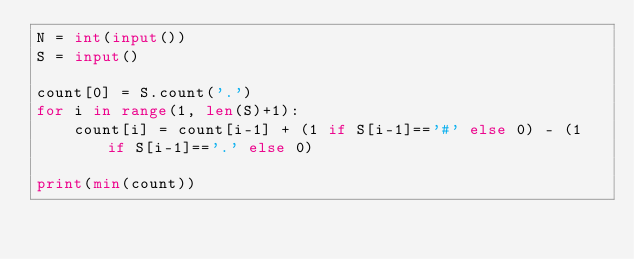<code> <loc_0><loc_0><loc_500><loc_500><_Python_>N = int(input())
S = input()
 
count[0] = S.count('.')
for i in range(1, len(S)+1):
    count[i] = count[i-1] + (1 if S[i-1]=='#' else 0) - (1 if S[i-1]=='.' else 0)

print(min(count))</code> 